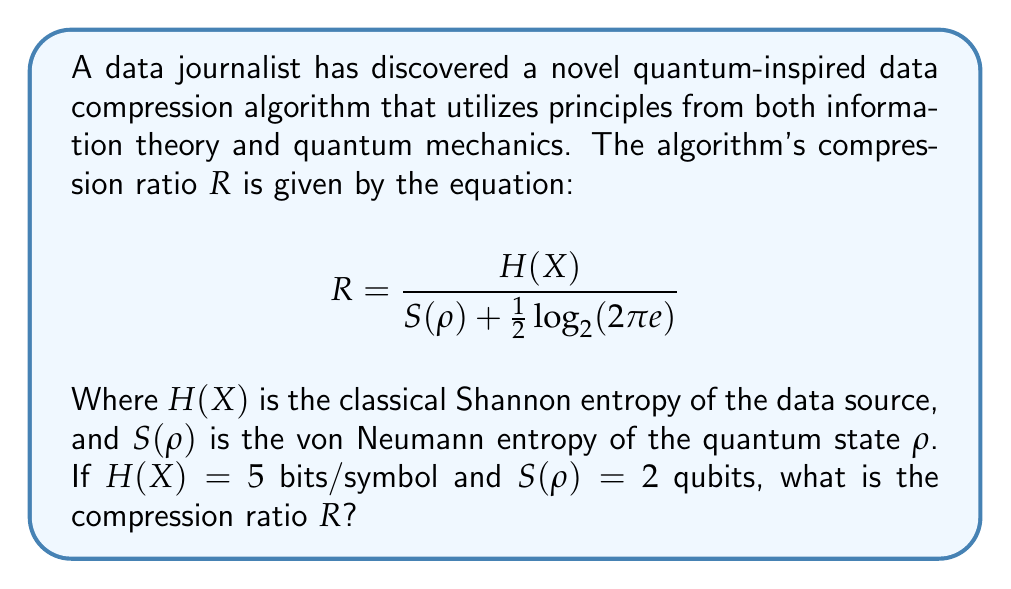What is the answer to this math problem? To solve this problem, we'll follow these steps:

1) Recall the given equation for the compression ratio:
   $$R = \frac{H(X)}{S(ρ) + \frac{1}{2}\log_2(2πe)}$$

2) We're given that $H(X) = 5$ bits/symbol and $S(ρ) = 2$ qubits.

3) We need to calculate $\frac{1}{2}\log_2(2πe)$:
   $\frac{1}{2}\log_2(2πe) ≈ 1.047$ bits

4) Now, let's substitute these values into the equation:
   $$R = \frac{5}{2 + 1.047}$$

5) Simplify:
   $$R = \frac{5}{3.047}$$

6) Calculate the final result:
   $$R ≈ 1.641$$

Therefore, the compression ratio $R$ is approximately 1.641.
Answer: $1.641$ 